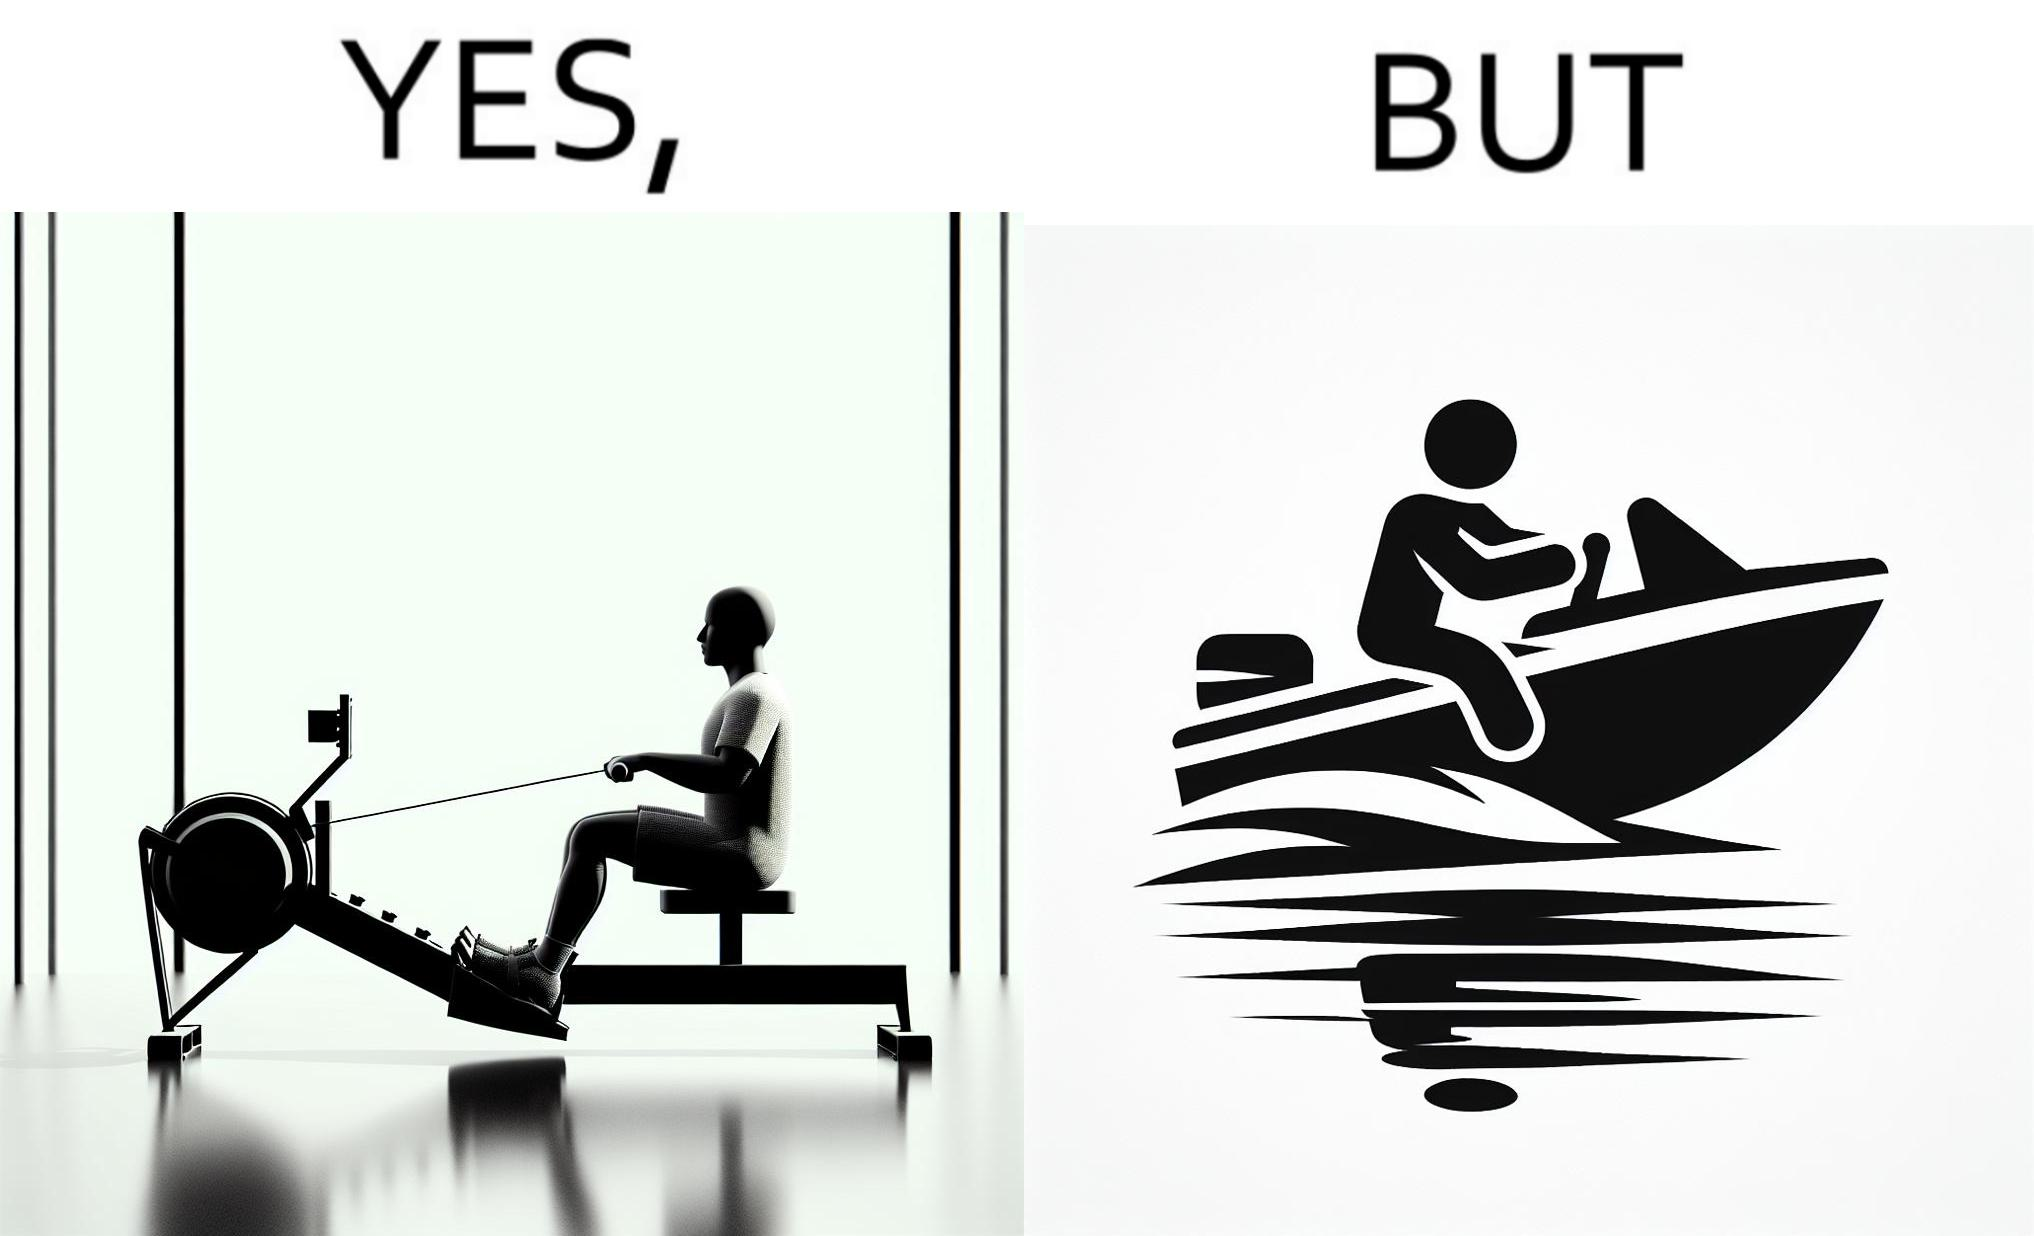Why is this image considered satirical? The image is ironic, because people often use rowing machine at the gym don't prefer rowing when it comes to boats 